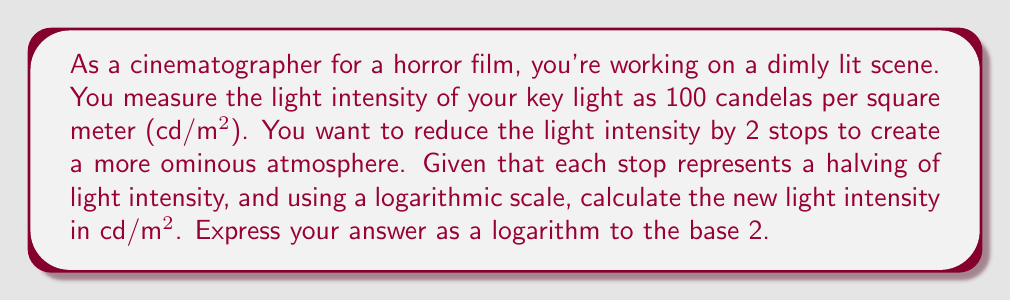Give your solution to this math problem. Let's approach this step-by-step:

1) First, recall that each stop represents a halving of light intensity. So, reducing by 2 stops means we're quartering the original intensity.

2) We can express this mathematically as:
   $$\text{New Intensity} = \frac{\text{Original Intensity}}{2^2} = \frac{100}{4} = 25 \text{ cd/m²}$$

3) Now, we need to express this as a logarithm to the base 2. The general form we're looking for is:
   $$25 = 2^x$$

4) Taking the logarithm of both sides:
   $$\log_2(25) = x$$

5) We can leave this as is, since $\log_2(25)$ is not a simple integer.

6) However, we can simplify it slightly using the change of base formula:
   $$\log_2(25) = \frac{\log(25)}{\log(2)}$$

   Where $\log$ without a base specified typically means the natural logarithm (base e).

7) This evaluates to approximately 4.64385619 but we'll keep it in logarithmic form for precision.
Answer: $\log_2(25)$ cd/m² or equivalently $\frac{\log(25)}{\log(2)}$ cd/m² 